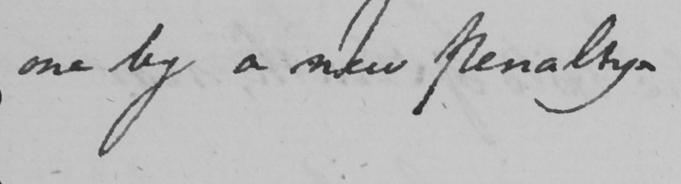Please provide the text content of this handwritten line. one by a new penalty . 